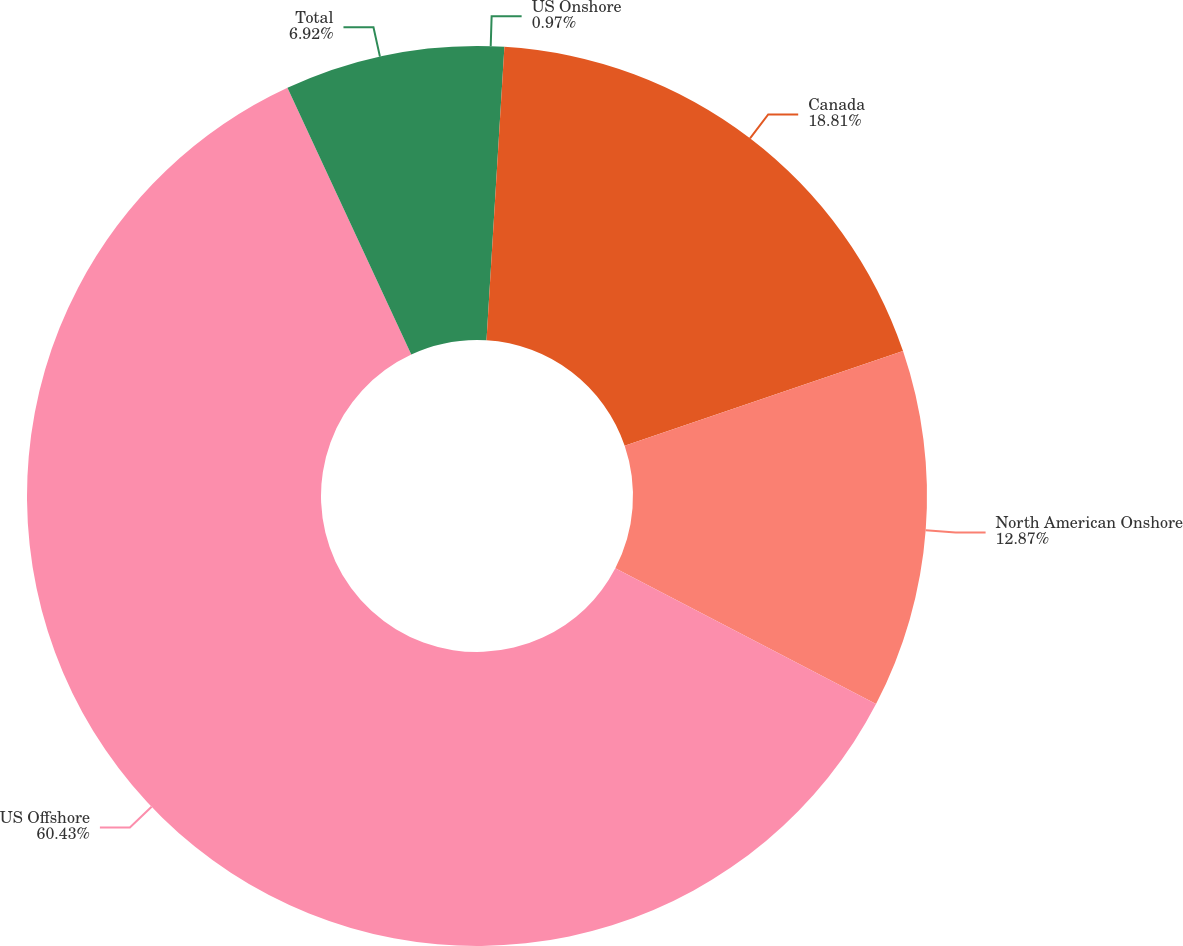<chart> <loc_0><loc_0><loc_500><loc_500><pie_chart><fcel>US Onshore<fcel>Canada<fcel>North American Onshore<fcel>US Offshore<fcel>Total<nl><fcel>0.97%<fcel>18.81%<fcel>12.87%<fcel>60.43%<fcel>6.92%<nl></chart> 